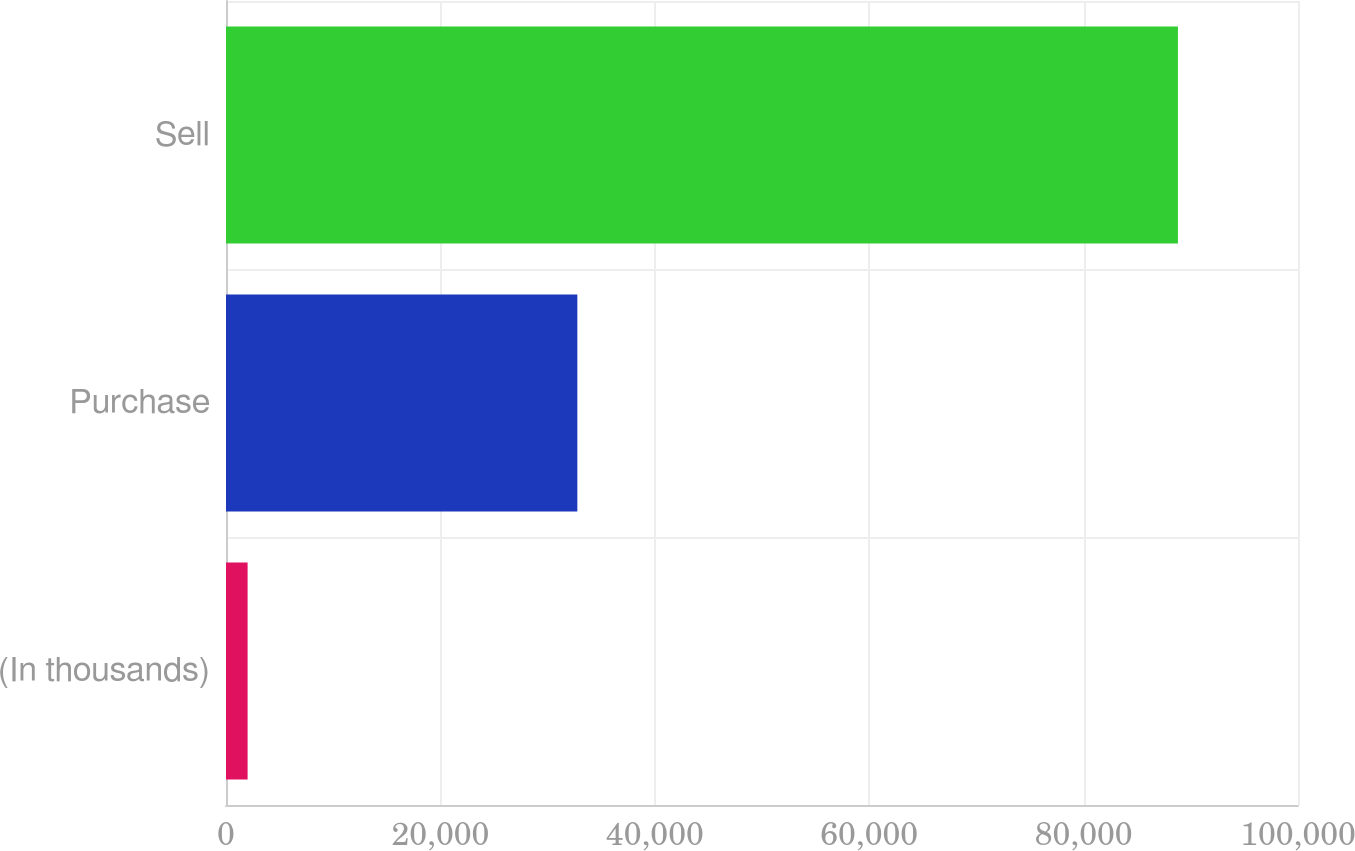<chart> <loc_0><loc_0><loc_500><loc_500><bar_chart><fcel>(In thousands)<fcel>Purchase<fcel>Sell<nl><fcel>2015<fcel>32775<fcel>88800<nl></chart> 